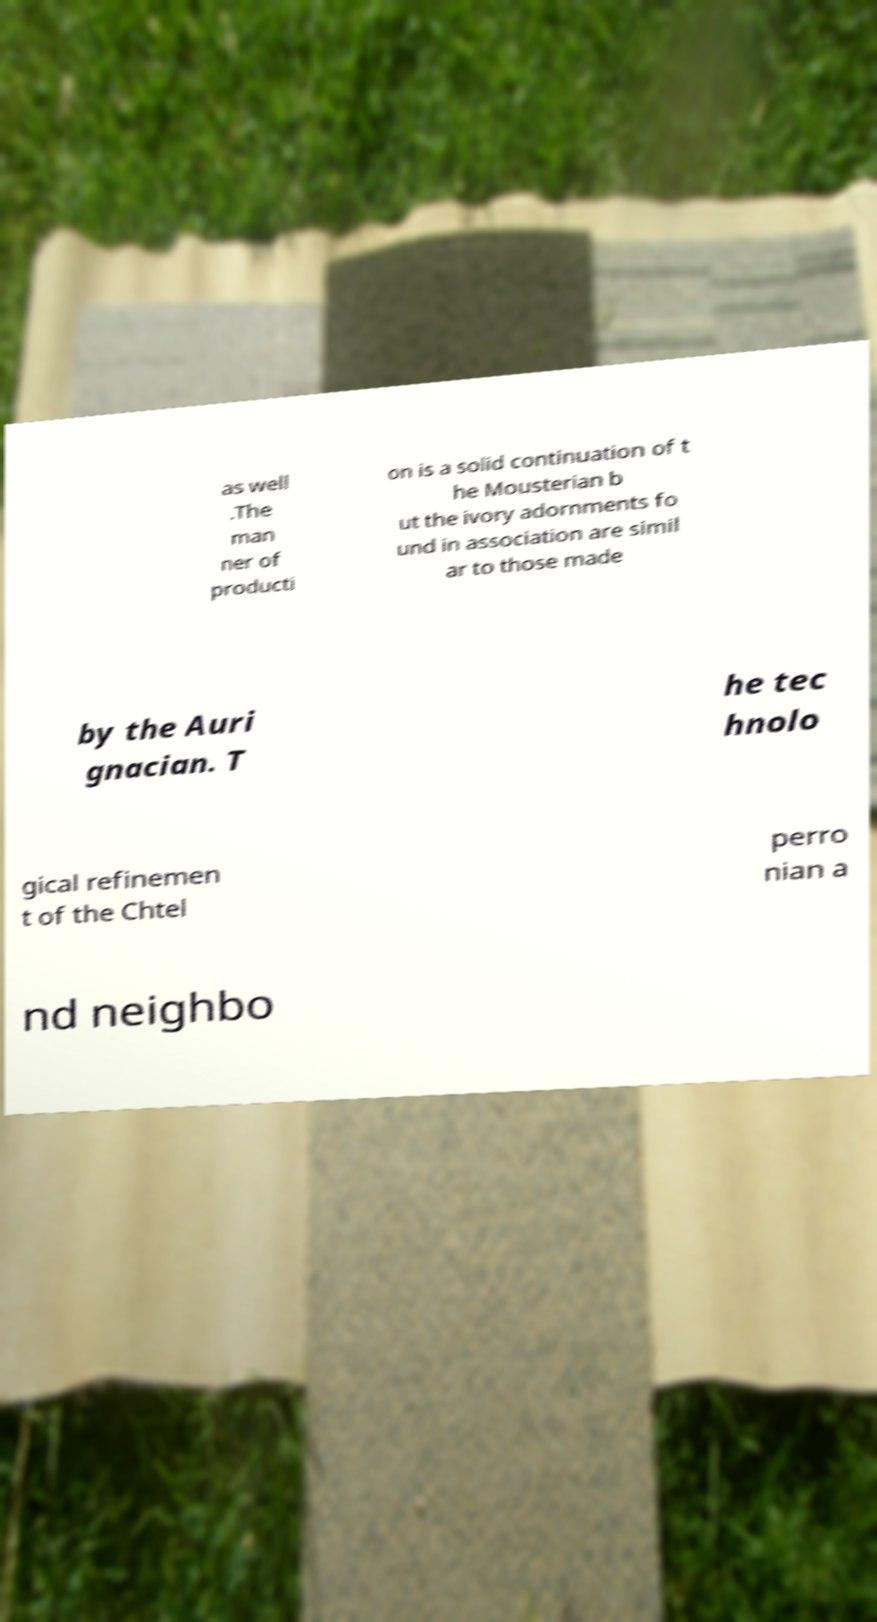Please identify and transcribe the text found in this image. as well .The man ner of producti on is a solid continuation of t he Mousterian b ut the ivory adornments fo und in association are simil ar to those made by the Auri gnacian. T he tec hnolo gical refinemen t of the Chtel perro nian a nd neighbo 